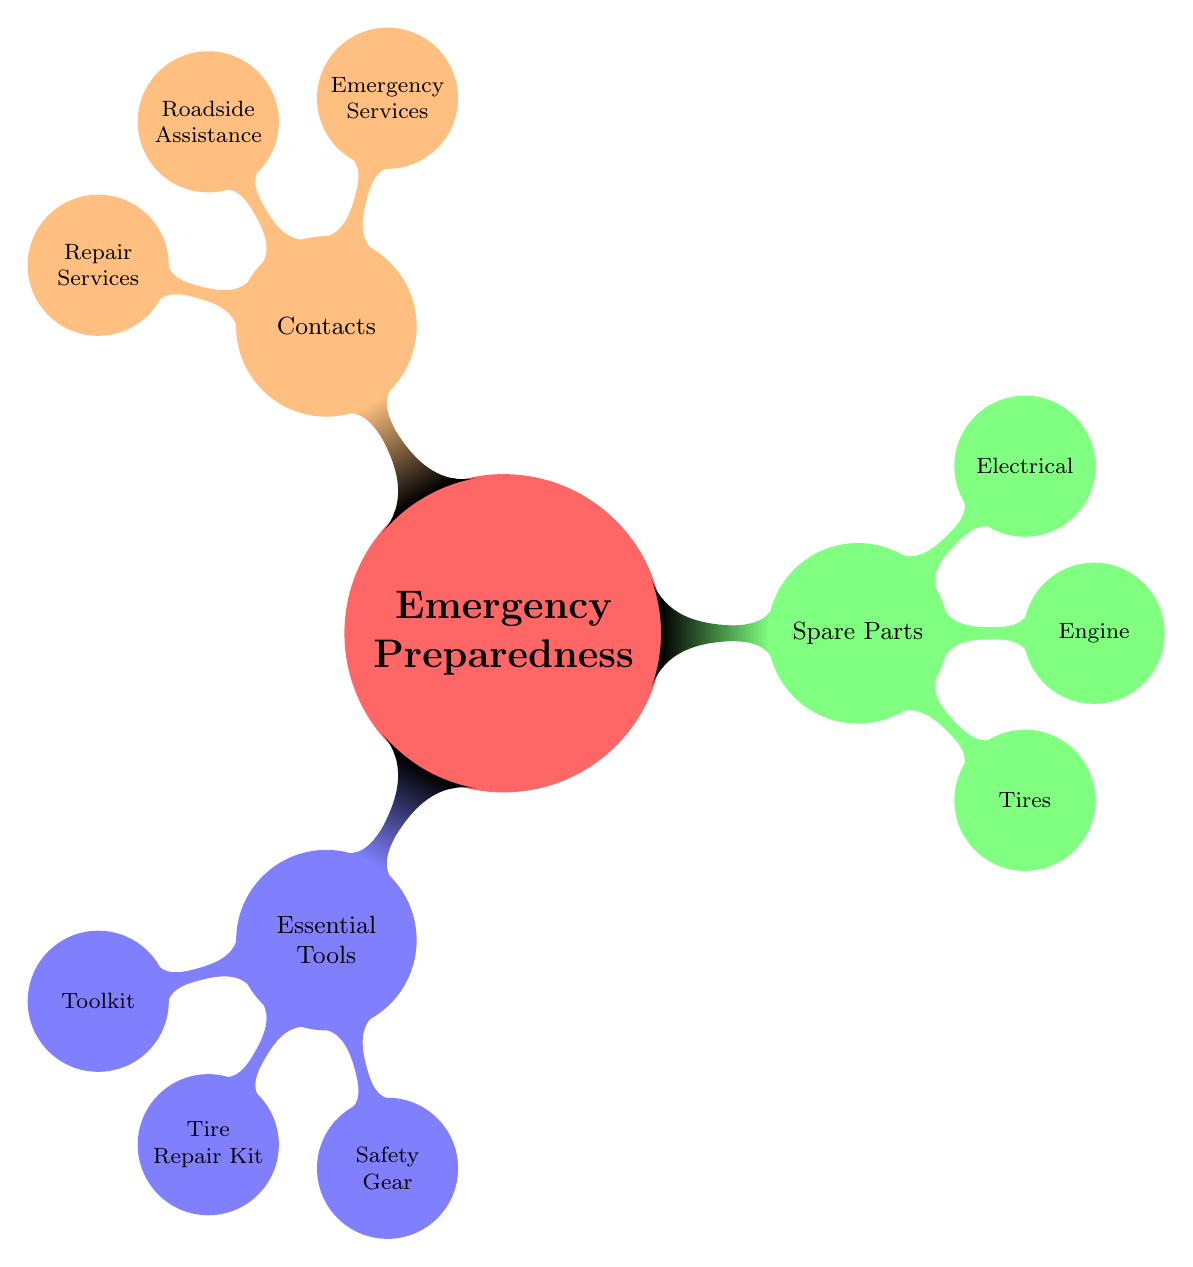What are three items included in the Toolkit? The Toolkit node under Essential Tools lists three specific items: Screwdrivers, Wrenches, and Pliers.
Answer: Screwdrivers, Wrenches, Pliers How many types of Spare Parts are listed in the diagram? The Spare Parts node contains three specific child nodes: Tires, Engine, and Electrical, indicating there are three types represented.
Answer: 3 What does the Tire Repair Kit contain? The Tire Repair Kit under Essential Tools has three components: Tire Plug Kit, Air Compressor, and Tire Pressure Gauge.
Answer: Tire Plug Kit, Air Compressor, Tire Pressure Gauge Which Emergency Services contact is listed in the diagram? The Emergency Services node identifies two specific contacts: 911 and Highway Patrol. Either of these can be seen as a valid answer.
Answer: 911 (or Highway Patrol) How are Essential Tools related to Emergency Preparedness? Essential Tools is a direct child node of Emergency Preparedness, indicating that it is a category that contributes to overall preparedness.
Answer: Essential Tools What is the content under Contacts regarding Repair Services? The Repair Services node lists two specific contacts: Local Mechanics and Truck Dealership Service Centers.
Answer: Local Mechanics, Truck Dealership Service Centers Which category contains the item "Full-size Spare Tire"? The "Full-size Spare Tire" is found under the Tires node, which is a sub-node of Spare Parts.
Answer: Spare Parts What is one example of Safety Gear listed in the diagram? Under the Safety Gear node, one specific item provided is the Reflective Vest, which is a safety-related tool.
Answer: Reflective Vest What are the components of the Electrical spare parts? The Electrical node lists two components: Fuses and Headlight Bulbs, detailing the types of electrical spare parts available.
Answer: Fuses, Headlight Bulbs 